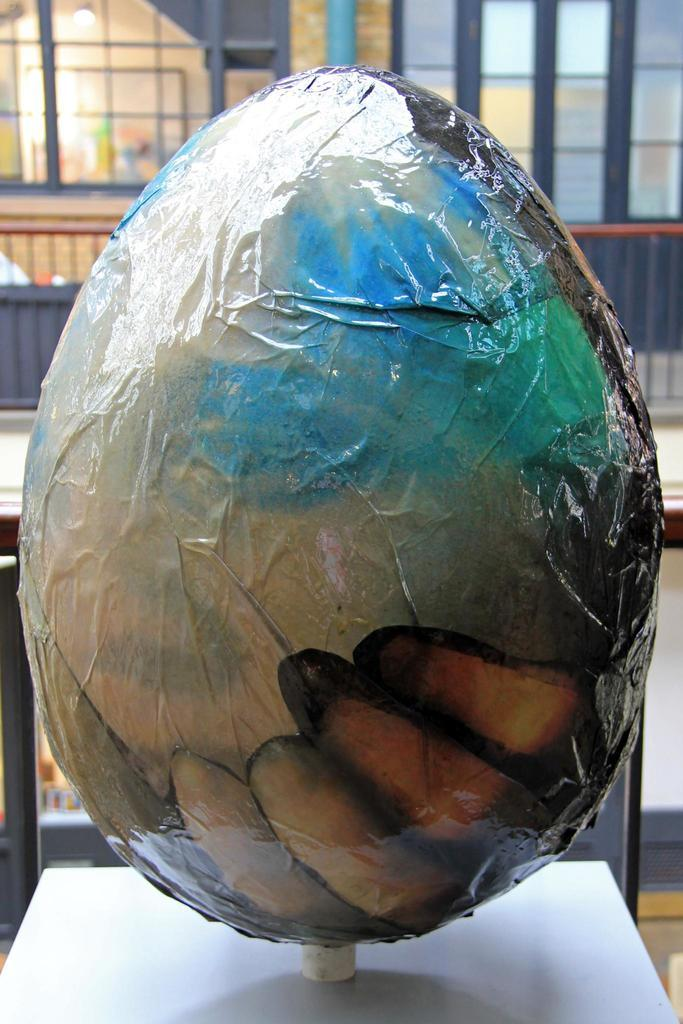What is located on the floor in the foreground of the image? There is an object on the floor in the foreground. What can be seen in the background of the image? There is a fence and buildings in the background. Can you describe the time of day when the image might have been taken? The image might have been taken during the day, as there is sufficient light to see the details. What type of brass instrument can be heard playing in the image? There is no brass instrument or sound present in the image, as it is a still photograph. 